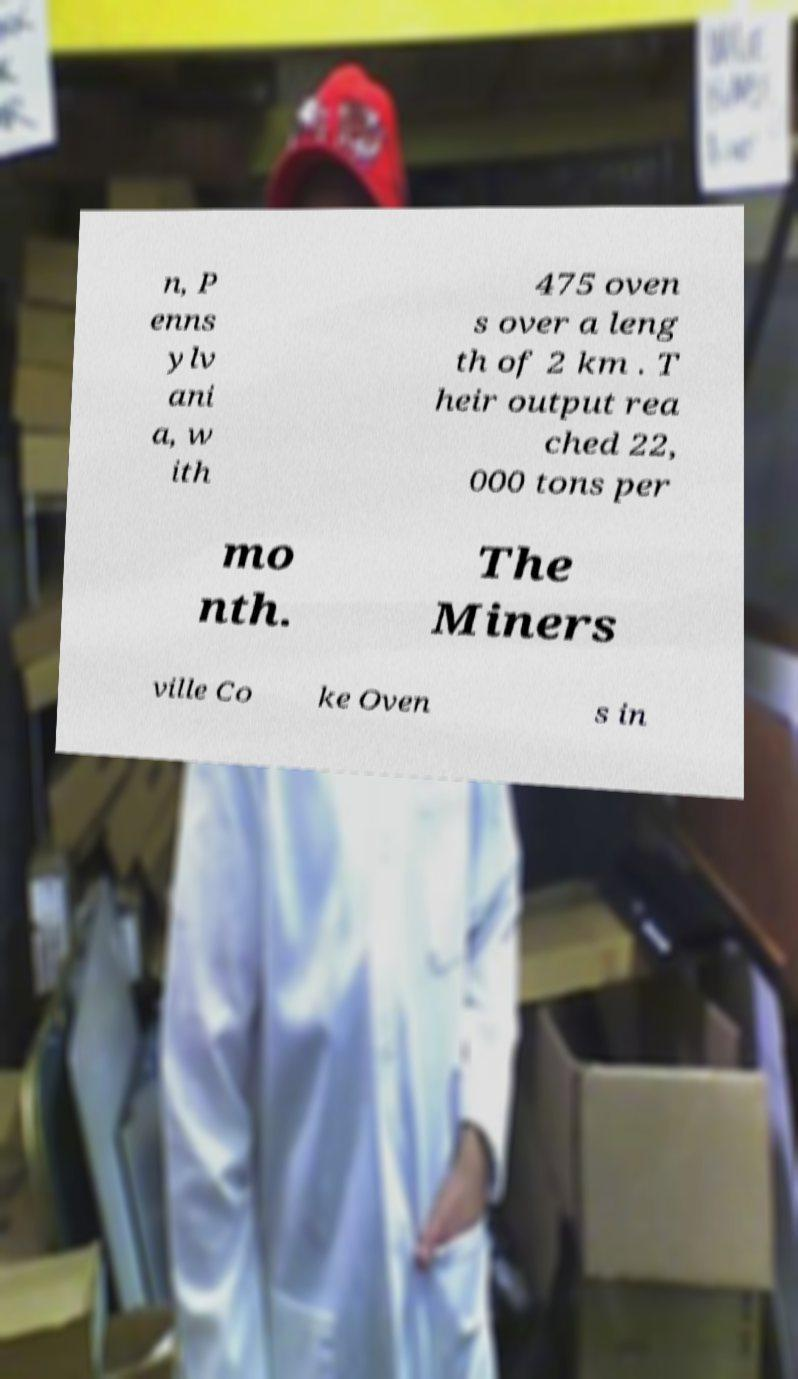There's text embedded in this image that I need extracted. Can you transcribe it verbatim? n, P enns ylv ani a, w ith 475 oven s over a leng th of 2 km . T heir output rea ched 22, 000 tons per mo nth. The Miners ville Co ke Oven s in 